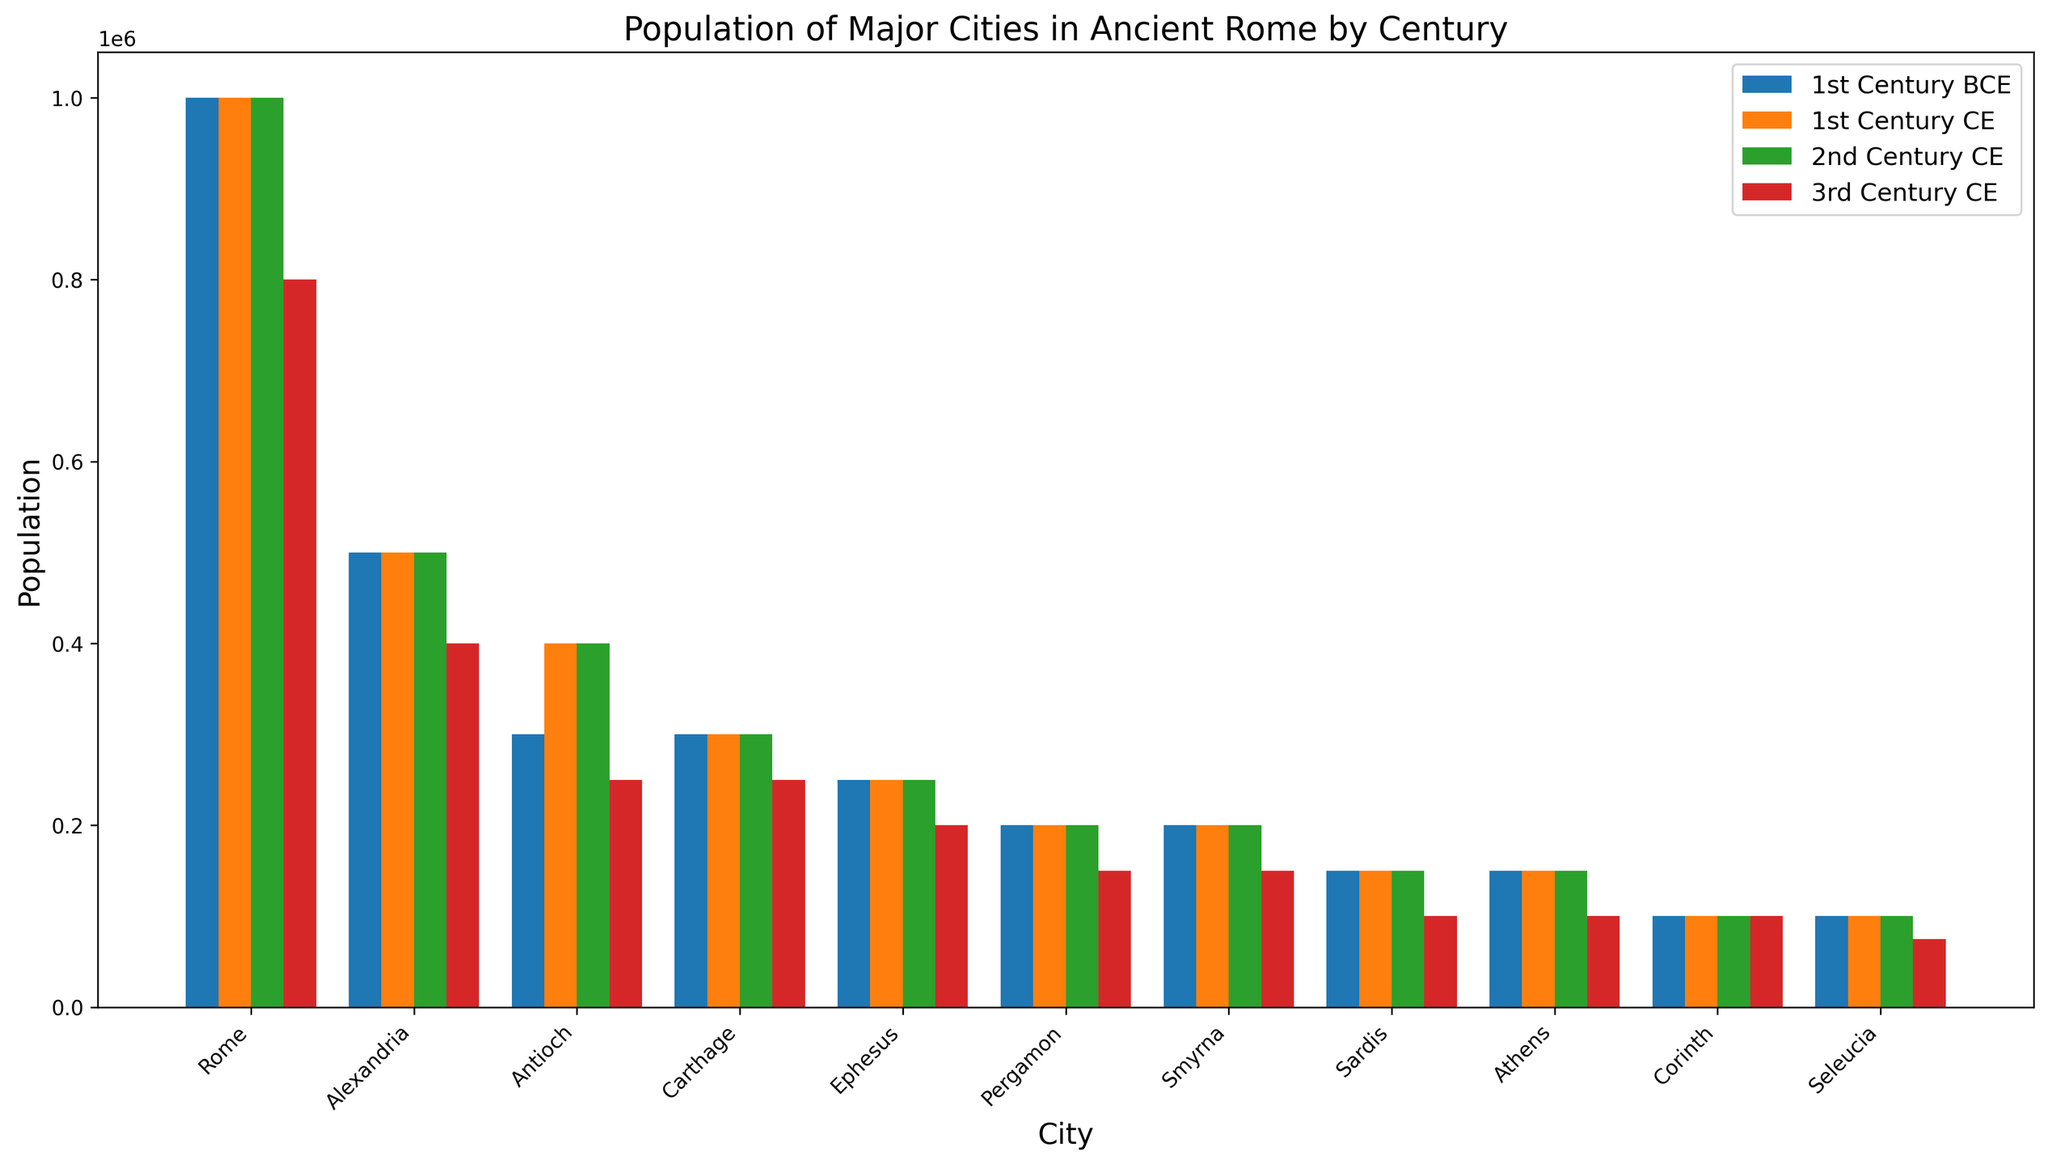Which city had the highest population in the 1st century CE? To find the city with the highest population in the 1st century CE, we simply look at the tallest bar among the bars representing the 1st century CE. Rome has the tallest bar indicating the largest population.
Answer: Rome Which cities had a constant population from the 1st century BCE to the 2nd century CE? To answer this, check the bars representing each century for each city and look for cities where the heights (populations) do not change across the 1st century BCE, 1st century CE, and 2nd century CE. Alexandria, Carthage, Ephesus, Pergamon, Smyrna, Sardis, Athens, and Corinth all have constant bar heights in these periods.
Answer: Alexandria, Carthage, Ephesus, Pergamon, Smyrna, Sardis, Athens, Corinth What is the total population of Alexandria across all the centuries mentioned? Sum the population of Alexandria for the 1st century BCE, 1st century CE, 2nd century CE, and 3rd century CE. So, 500,000 + 500,000 + 500,000 + 400,000 = 1,900,000.
Answer: 1,900,000 Which city saw the largest population decrease from the 2nd century CE to the 3rd century CE? For each city, subtract the population in the 3rd century CE from its population in the 2nd century CE. Compare these values to find the largest decrease. Rome’s population decreased by 200,000.
Answer: Rome Compare the population of Antioch in the 1st century BCE and the 1st century CE. Which century had a higher population? To compare, look at the heights of the bars for Antioch in the 1st century BCE and the 1st century CE. The 1st century CE bar is taller with a population of 400,000, compared to 300,000 in the 1st century BCE.
Answer: 1st century CE What is the average population of Athens across all the centuries? Add the populations of Athens from the 1st century BCE, 1st century CE, 2nd century CE, and 3rd century CE, then divide by the number of centuries. (150,000 + 150,000 + 150,000 + 100,000) / 4 = 137,500.
Answer: 137,500 How does the population of Carthage in the 3rd century CE compare to its population in the 1st century BCE? Compare the height of the bar for Carthage in the 3rd century CE to the bar in the 1st century BCE. The population decreased from 300,000 in the 1st century BCE to 250,000 in the 3rd century CE.
Answer: Decreased Which city had the smallest population in the 3rd century CE? To find the smallest population, look at the shortest bar among the bars representing the 3rd century CE. Seleucia had the shortest bar with a population of 75,000.
Answer: Seleucia 